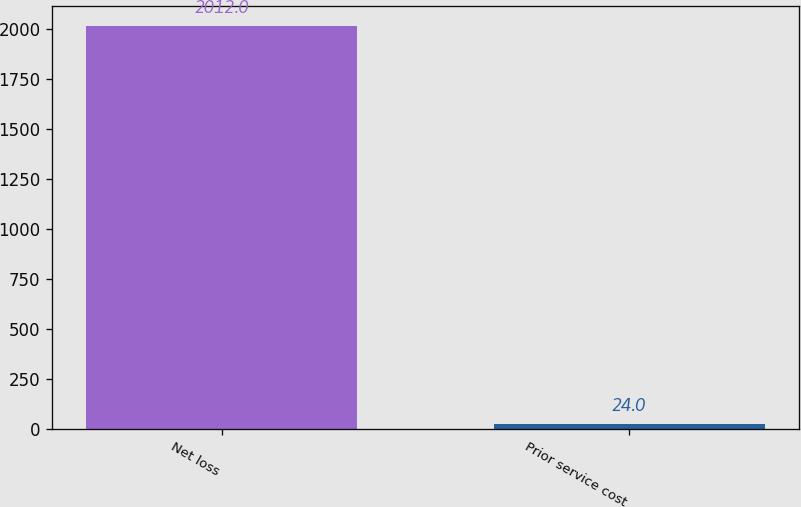Convert chart. <chart><loc_0><loc_0><loc_500><loc_500><bar_chart><fcel>Net loss<fcel>Prior service cost<nl><fcel>2012<fcel>24<nl></chart> 